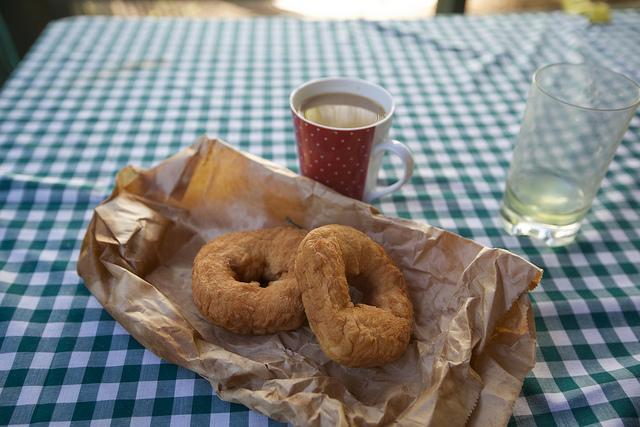What type of donuts are these? cake 